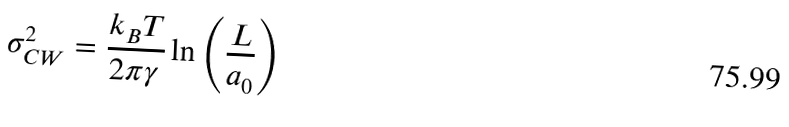<formula> <loc_0><loc_0><loc_500><loc_500>\sigma _ { C W } ^ { 2 } = \frac { k _ { B } T } { 2 \pi \gamma } \ln \left ( \frac { L } { a _ { 0 } } \right )</formula> 